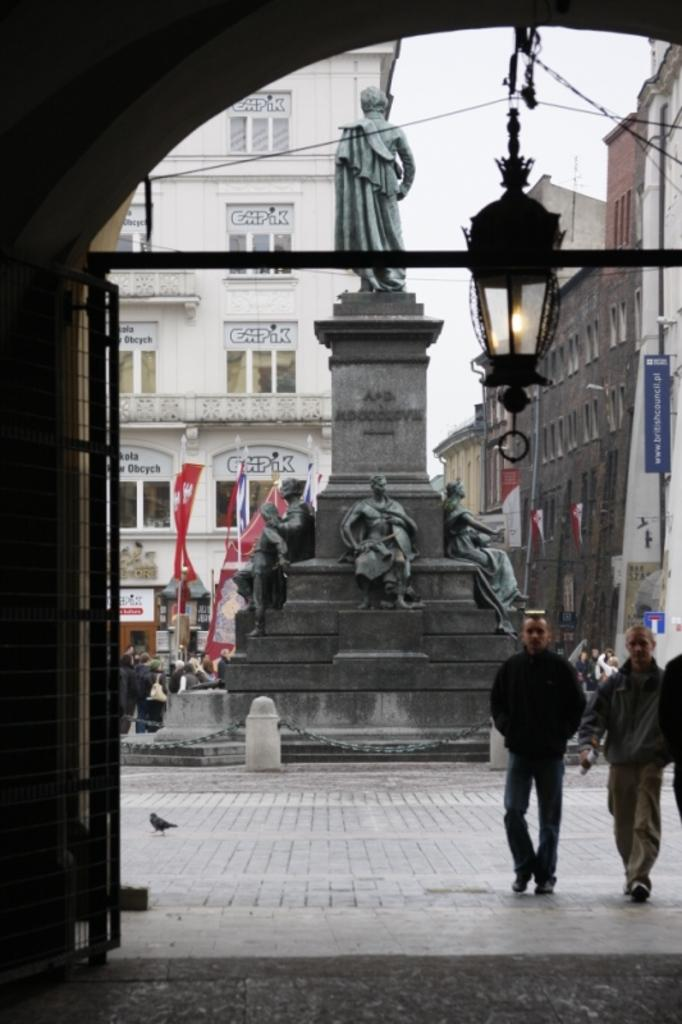What is the main subject in the middle of the image? There is a statue in the middle of the image. What type of structures can be seen in the image? There are buildings in the image. What are the persons in the image doing? The persons walking on the right side of the image are walking. What is the hour on the club's sign in the image? There is no club or sign present in the image. What type of slope can be seen in the image? There is no slope visible in the image. 